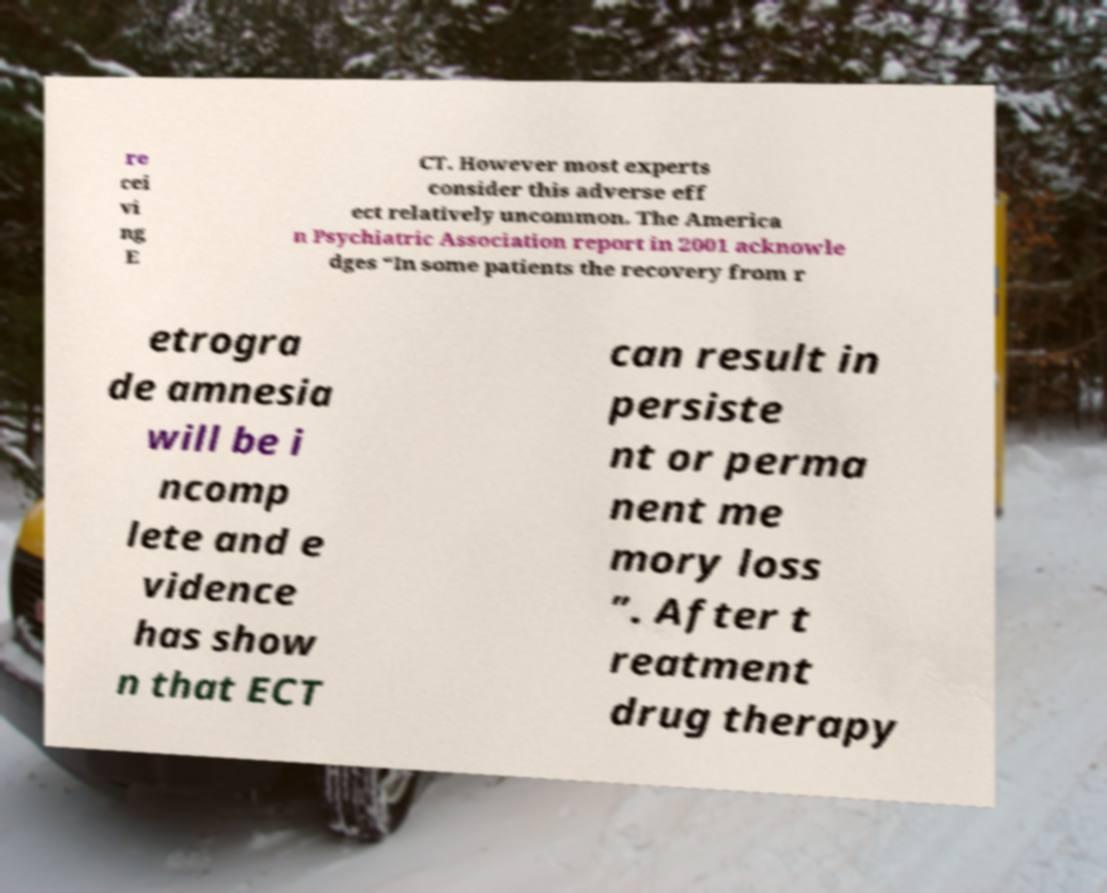Could you assist in decoding the text presented in this image and type it out clearly? re cei vi ng E CT. However most experts consider this adverse eff ect relatively uncommon. The America n Psychiatric Association report in 2001 acknowle dges “In some patients the recovery from r etrogra de amnesia will be i ncomp lete and e vidence has show n that ECT can result in persiste nt or perma nent me mory loss ”. After t reatment drug therapy 